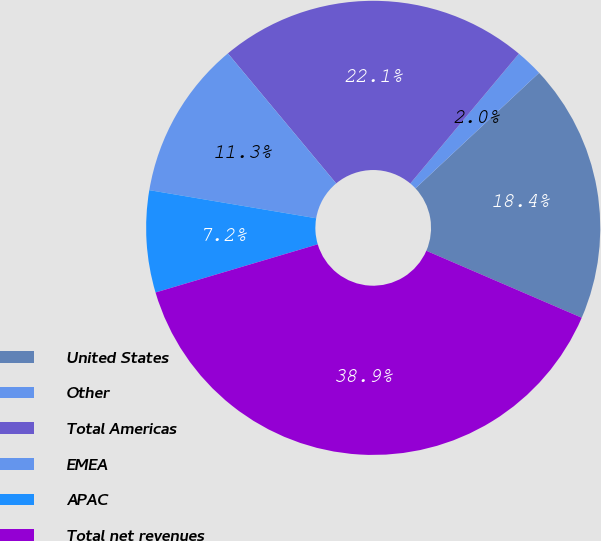<chart> <loc_0><loc_0><loc_500><loc_500><pie_chart><fcel>United States<fcel>Other<fcel>Total Americas<fcel>EMEA<fcel>APAC<fcel>Total net revenues<nl><fcel>18.44%<fcel>1.95%<fcel>22.14%<fcel>11.29%<fcel>7.25%<fcel>38.93%<nl></chart> 